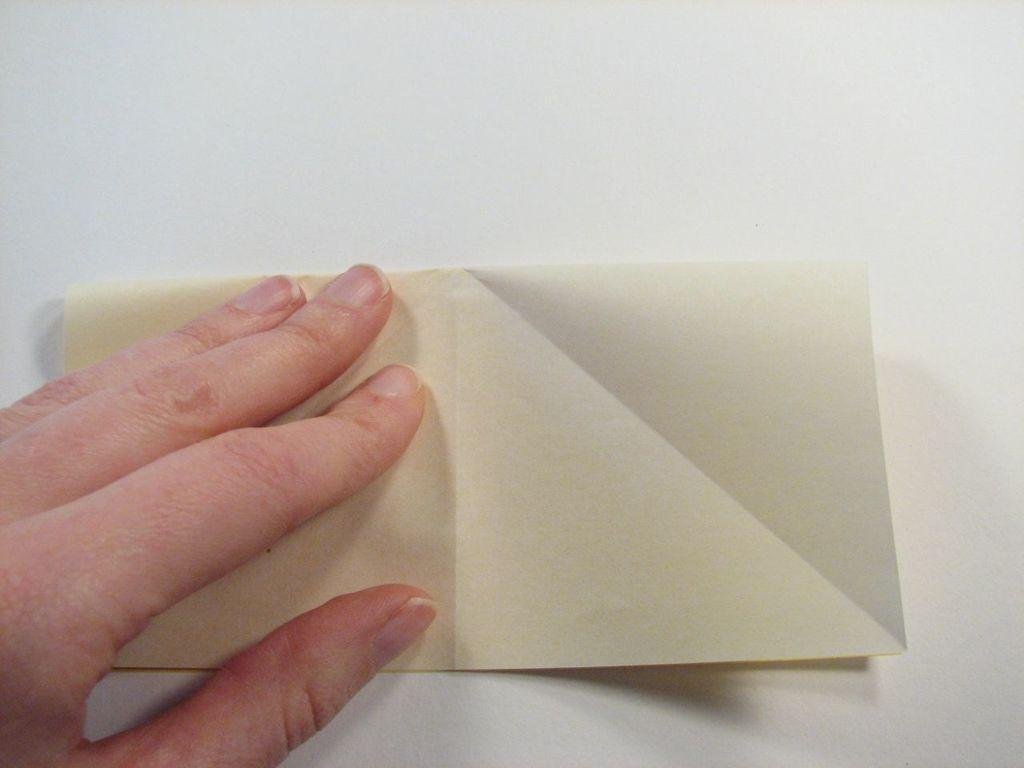What part of the human body is visible in the image? There is a human hand in the image. What object is being held or touched by the hand in the image? There is a paper in the image. What type of surface is the hand and paper placed on in the image? There is a white surface in the image. How many bags are visible on the mountain in the image? There are no bags or mountains present in the image. How many chairs are visible in the image? There are no chairs present in the image. 